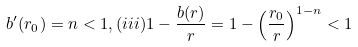Convert formula to latex. <formula><loc_0><loc_0><loc_500><loc_500>b ^ { \prime } ( r _ { 0 } ) = n < 1 , ( i i i ) 1 - \frac { b ( r ) } { r } = 1 - \left ( \frac { r _ { 0 } } { r } \right ) ^ { 1 - n } < 1</formula> 